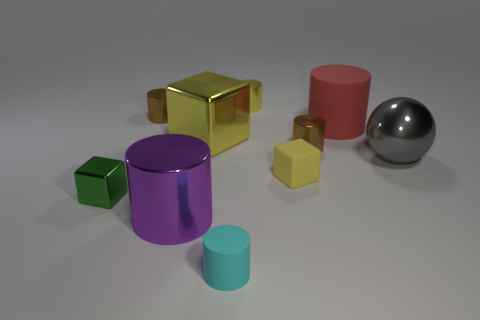How many metallic objects are small gray things or yellow things?
Provide a succinct answer. 2. Do the large metallic cube and the big ball have the same color?
Provide a succinct answer. No. Is the number of brown cylinders that are in front of the sphere greater than the number of large purple metallic things?
Give a very brief answer. No. How many other objects are there of the same material as the ball?
Make the answer very short. 6. How many large objects are red objects or cyan metal things?
Give a very brief answer. 1. Is the material of the purple object the same as the gray object?
Provide a succinct answer. Yes. What number of tiny brown metallic cylinders are on the right side of the brown thing that is in front of the large matte cylinder?
Your answer should be very brief. 0. Are there any red matte objects that have the same shape as the yellow matte thing?
Give a very brief answer. No. There is a matte object that is in front of the green thing; is its shape the same as the brown shiny thing that is in front of the big matte cylinder?
Provide a short and direct response. Yes. What shape is the tiny object that is in front of the large red cylinder and behind the gray sphere?
Make the answer very short. Cylinder. 